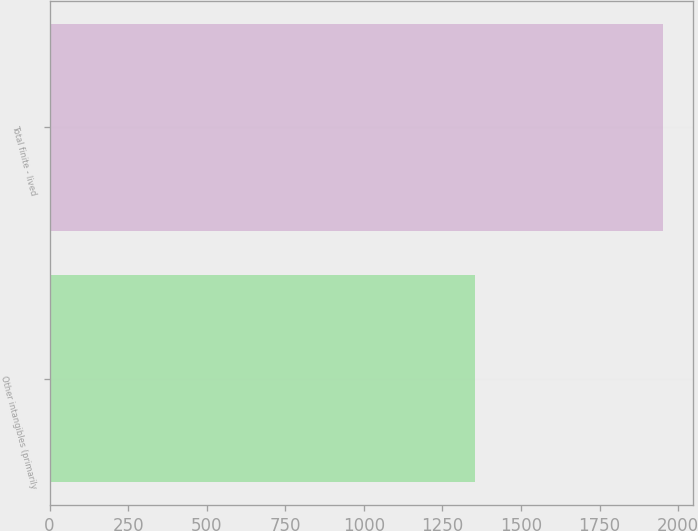Convert chart to OTSL. <chart><loc_0><loc_0><loc_500><loc_500><bar_chart><fcel>Other intangibles (primarily<fcel>Total finite - lived<nl><fcel>1354<fcel>1951<nl></chart> 